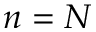<formula> <loc_0><loc_0><loc_500><loc_500>n = N</formula> 